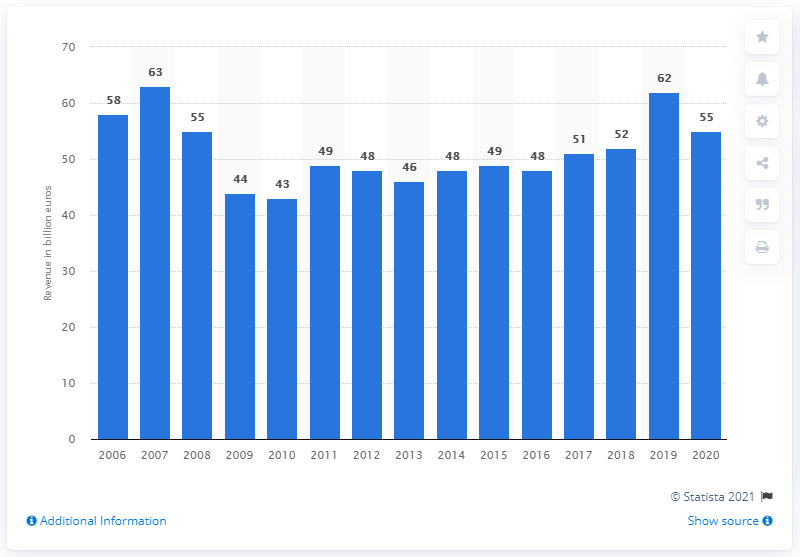Specify some key components in this picture. The estimated revenue of France's mechanical engineering industry in 2020 was $55 million. 